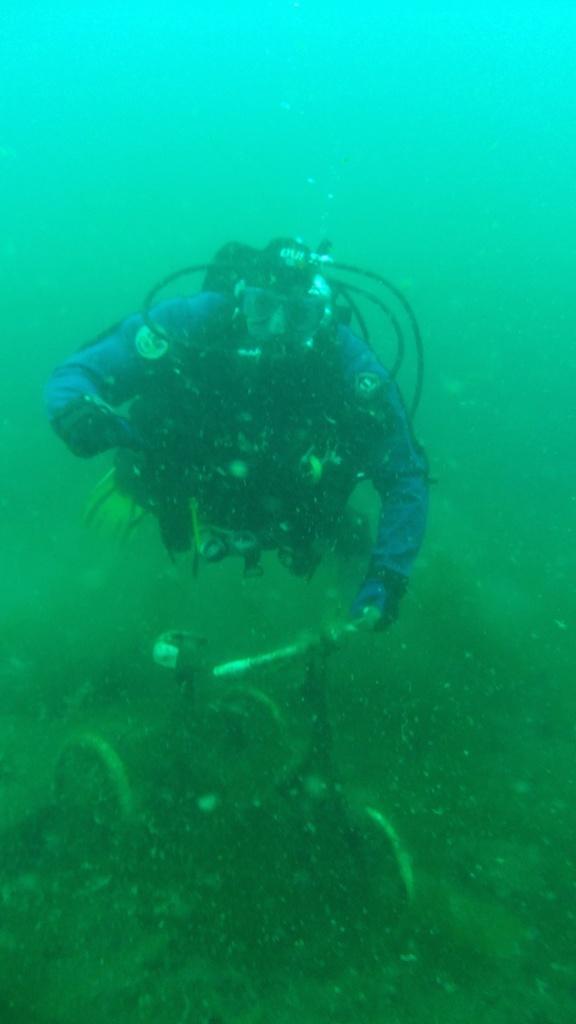Could you give a brief overview of what you see in this image? In this picture there is a man wearing blue color costume dress with mask and oxygen cylinder swimming under the sea. Behind there is blue water. 